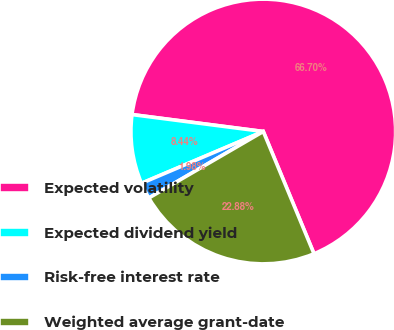<chart> <loc_0><loc_0><loc_500><loc_500><pie_chart><fcel>Expected volatility<fcel>Expected dividend yield<fcel>Risk-free interest rate<fcel>Weighted average grant-date<nl><fcel>66.7%<fcel>8.44%<fcel>1.98%<fcel>22.88%<nl></chart> 